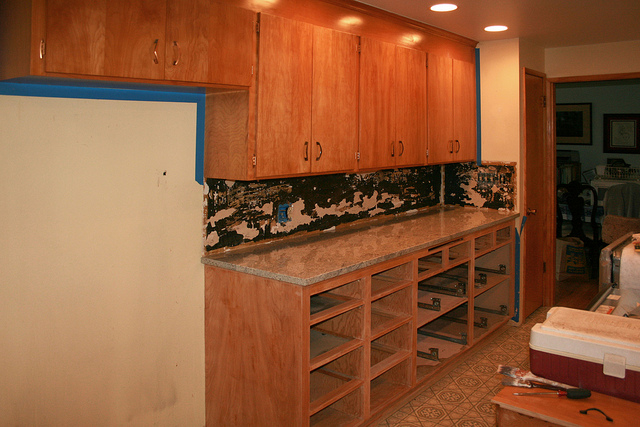<image>What color are the drawers? There are no drawers in the image. However, they can be seen as brown or oak. What color are the drawers? The drawers are brown in color. 